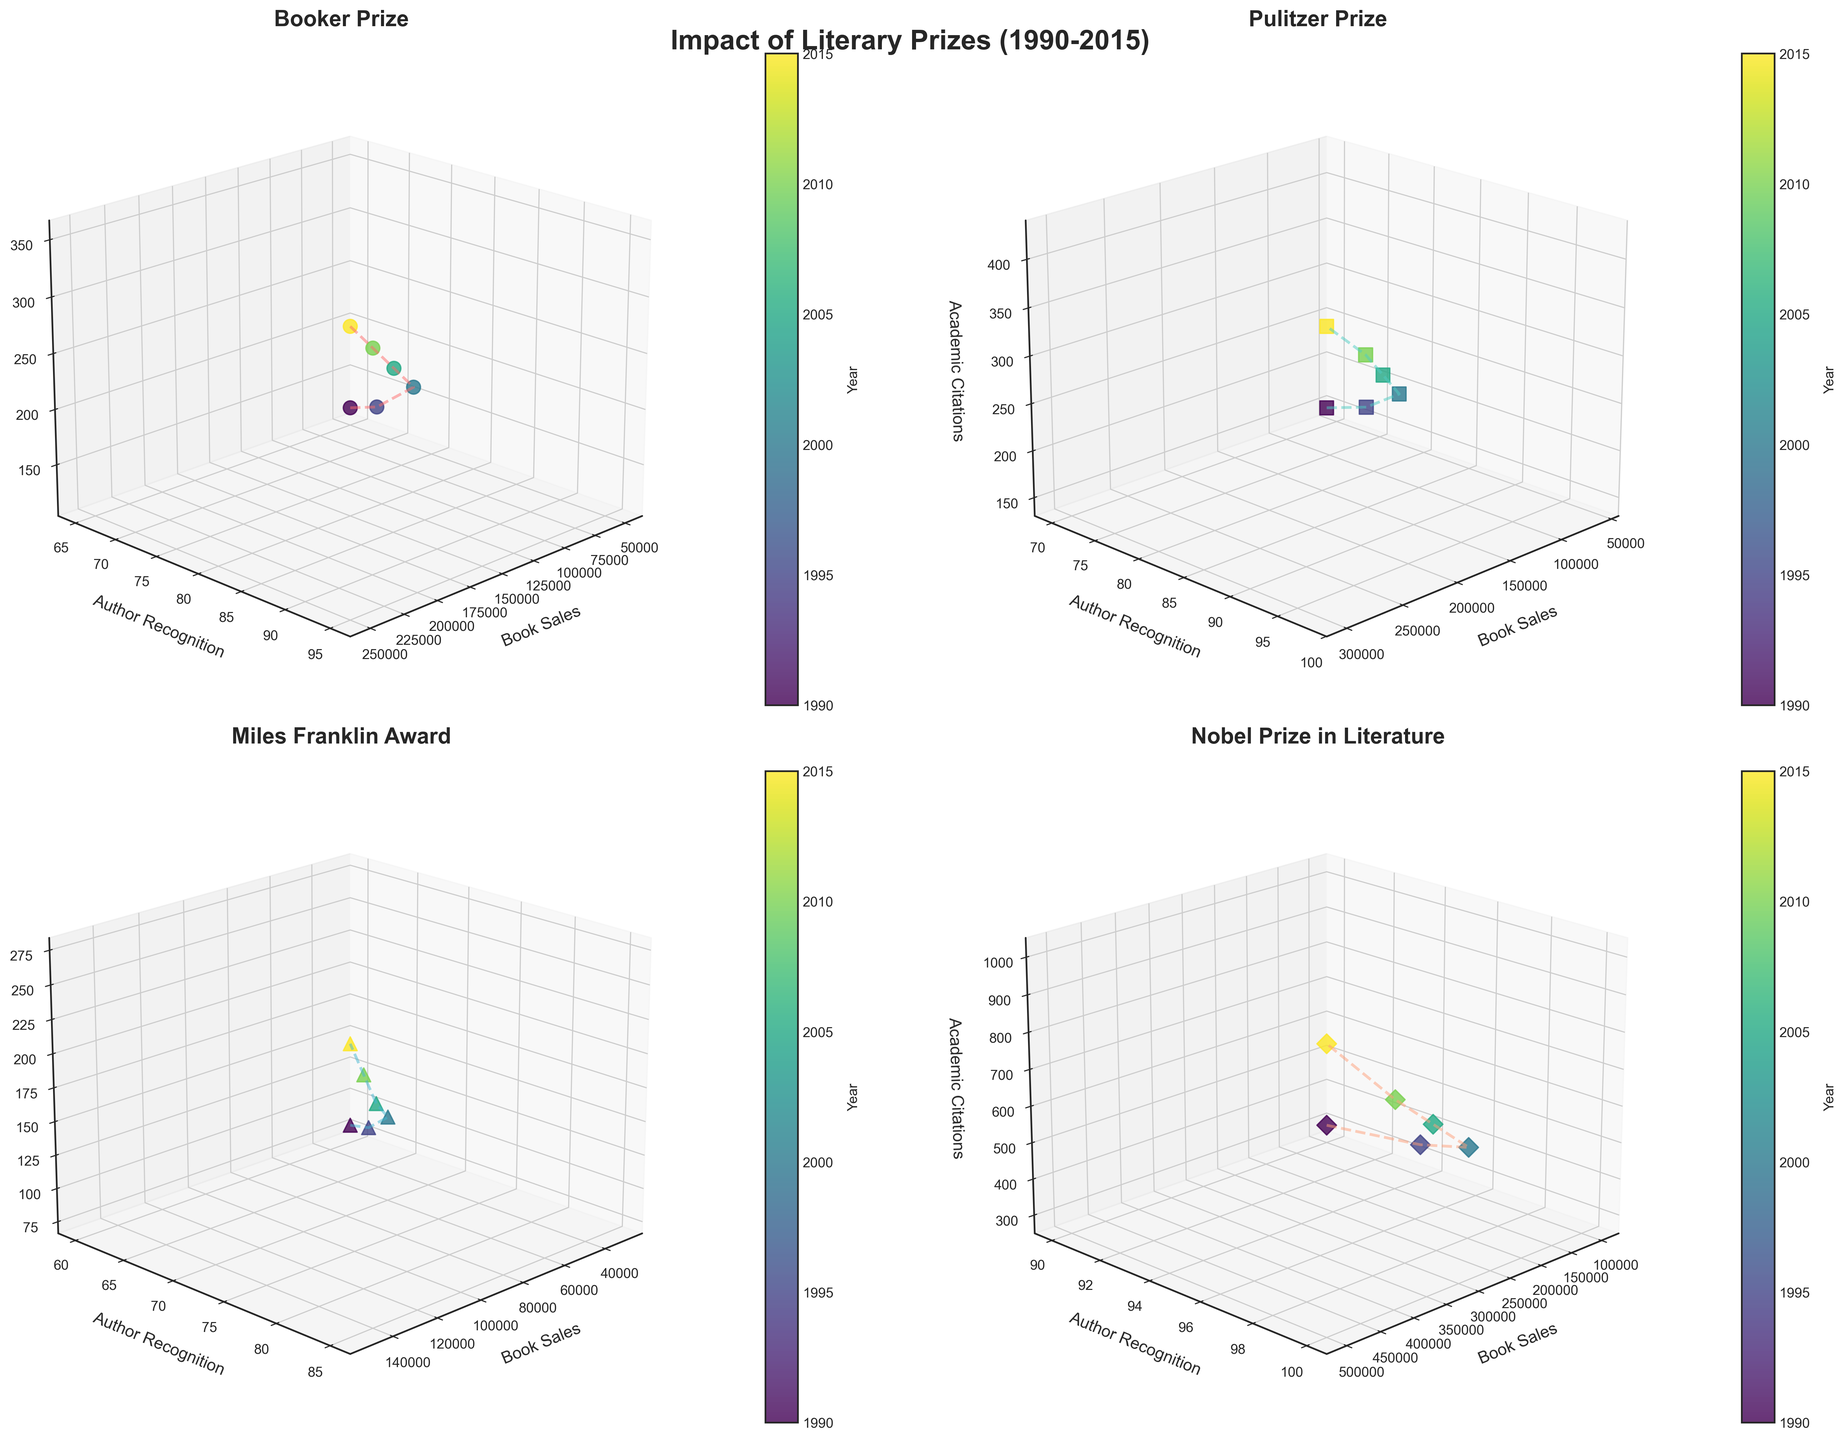Which prize showed the highest book sales in 2015? Look at the data points corresponding to 2015 for each subplot and identify the highest value on the book sales axis.
Answer: Nobel Prize in Literature What is the range of academic citations for the Booker Prize subplot? Identify the minimum and maximum academic citations values from the Booker Prize subplot and compute the range. The range is the difference between the maximum and the minimum values.
Answer: 230 How does author recognition change over time for the Pulitzer Prize subplot? Track the data points along the author recognition axis within the Pulitzer Prize subplot from 1990 to 2015 and describe the trend.
Answer: Increasing Which prize had the highest academic citations in 2005? Locate the data points corresponding to 2005 in each subplot and identify the highest value on the academic citations axis.
Answer: Nobel Prize in Literature Compare the author recognition between the Nobel Prize in Literature and Miles Franklin Award in 1995. Which is higher? Locate the data points corresponding to 1995 in both subplots and compare the values on the author recognition axis.
Answer: Nobel Prize in Literature What is the trend of book sales for the Booker Prize subplot from 1990 through 2015? Examine the data points along the book sales axis within the Booker Prize subplot from 1990 to 2015 and describe the trend.
Answer: Increasing Which continent shows the most significant increase in author recognition over time for their literary prize? Review each subplot and evaluate the change in author recognition values from 1990 to 2015. Identify the continent with the most significant increase.
Answer: Global (Nobel Prize in Literature) How do the academic citations for the Nobel Prize in Literature compare to those of the Pulitzer Prize in 2010? Locate the data points corresponding to 2010 in both subplots and compare the values on the academic citations axis.
Answer: Nobel Prize in Literature Are there any overlapping data points in terms of book sales and author recognition for the Miles Franklin Award and the Booker Prize? Examine the scatter points within the Miles Franklin Award and Booker Prize subplots to see if any points have the same book sales and author recognition values.
Answer: No Which prize shows the most consistent increase in book sales over the years? Evaluate the book sales trends in each subplot to determine which prize has the most linear or consistent increase from 1990 to 2015.
Answer: Nobel Prize in Literature 